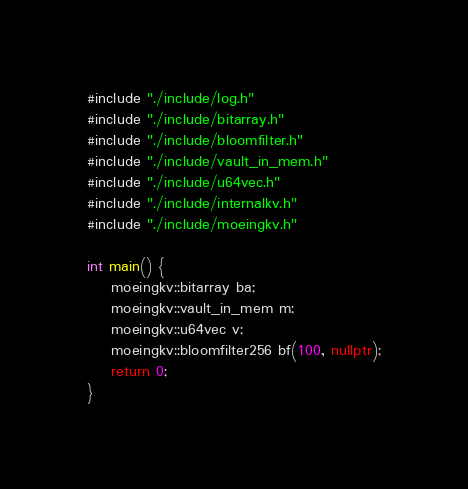Convert code to text. <code><loc_0><loc_0><loc_500><loc_500><_C++_>#include "./include/log.h"
#include "./include/bitarray.h"
#include "./include/bloomfilter.h"
#include "./include/vault_in_mem.h"
#include "./include/u64vec.h"
#include "./include/internalkv.h"
#include "./include/moeingkv.h"

int main() {
	moeingkv::bitarray ba;
	moeingkv::vault_in_mem m;
	moeingkv::u64vec v;
	moeingkv::bloomfilter256 bf(100, nullptr);
	return 0;
}	
</code> 